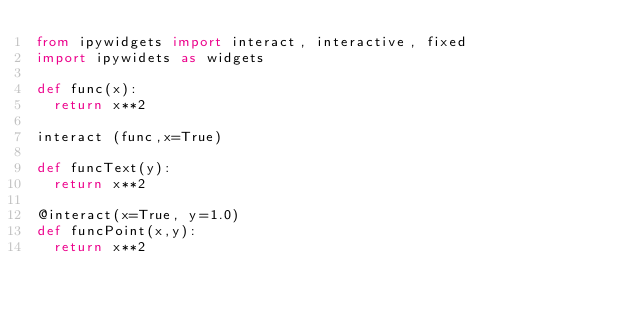Convert code to text. <code><loc_0><loc_0><loc_500><loc_500><_Python_>from ipywidgets import interact, interactive, fixed
import ipywidets as widgets

def func(x):
	return x**2

interact (func,x=True)

def funcText(y):
	return x**2

@interact(x=True, y=1.0)
def funcPoint(x,y):
	return x**2
</code> 